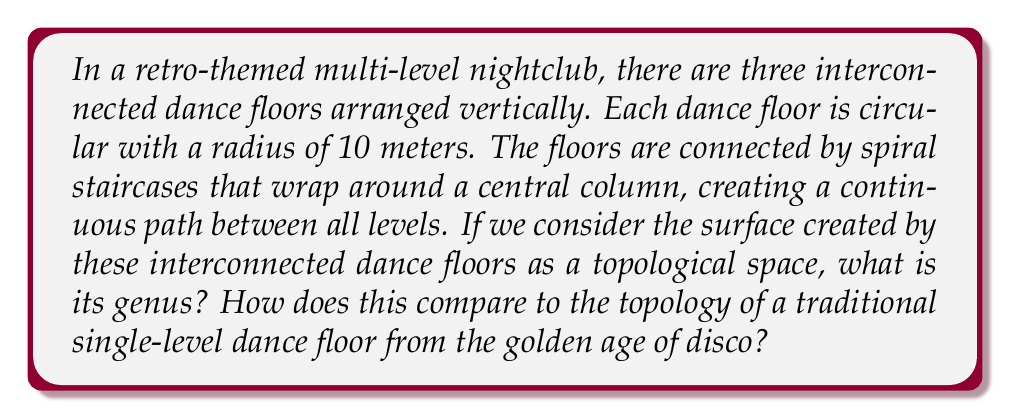Can you solve this math problem? Let's approach this step-by-step:

1) First, we need to understand what we're dealing with topologically. The three circular dance floors connected by spiral staircases essentially form a surface that's similar to a thick disk with two handles.

2) In topology, the genus of a surface is the number of handles or "holes" it has. It's a fundamental topological invariant.

3) To visualize this, imagine:
   - The bottom floor is like the base of a disk
   - The spiral staircases to the second floor form one handle
   - The spiral staircases from the second to the third floor form another handle

4) Mathematically, we can represent this surface as:

   $$S = D^2 \# T^2 \# T^2$$

   Where $D^2$ is a 2-dimensional disk (the base floor), and $T^2$ is a torus (each set of spiral staircases).

5) The genus of a connected sum of surfaces is the sum of their genera:

   $$g(S_1 \# S_2) = g(S_1) + g(S_2)$$

6) We know that:
   - $g(D^2) = 0$ (a disk has no handles)
   - $g(T^2) = 1$ (a torus has one handle)

7) Therefore, the genus of our multi-level dance floor is:

   $$g(S) = g(D^2) + g(T^2) + g(T^2) = 0 + 1 + 1 = 2$$

8) In contrast, a traditional single-level dance floor from the disco era would topologically be equivalent to a disk, which has a genus of 0.

[asy]
import geometry;

size(200);

// Draw the three levels
draw(circle((0,0),1), blue);
draw(circle((0,0),0.8), blue);
draw(circle((0,0),0.6), blue);

// Draw the connecting spirals
path spiral1 = (0.9,0.1){dir(80)}..{dir(100)}(0.7,0.1);
path spiral2 = (0.7,0.1){dir(80)}..{dir(100)}(0.5,0.1);

draw(spiral1, red+1);
draw(spiral2, red+1);
draw(rotate(120)*spiral1, red+1);
draw(rotate(120)*spiral2, red+1);
draw(rotate(240)*spiral1, red+1);
draw(rotate(240)*spiral2, red+1);

label("Level 1", (0,-1.1), S);
label("Level 2", (0,-0.9), S);
label("Level 3", (0,-0.7), S);
[/asy]
Answer: The genus of the multi-level dance floor topology is 2. This is in contrast to a traditional single-level disco dance floor, which has a genus of 0. 